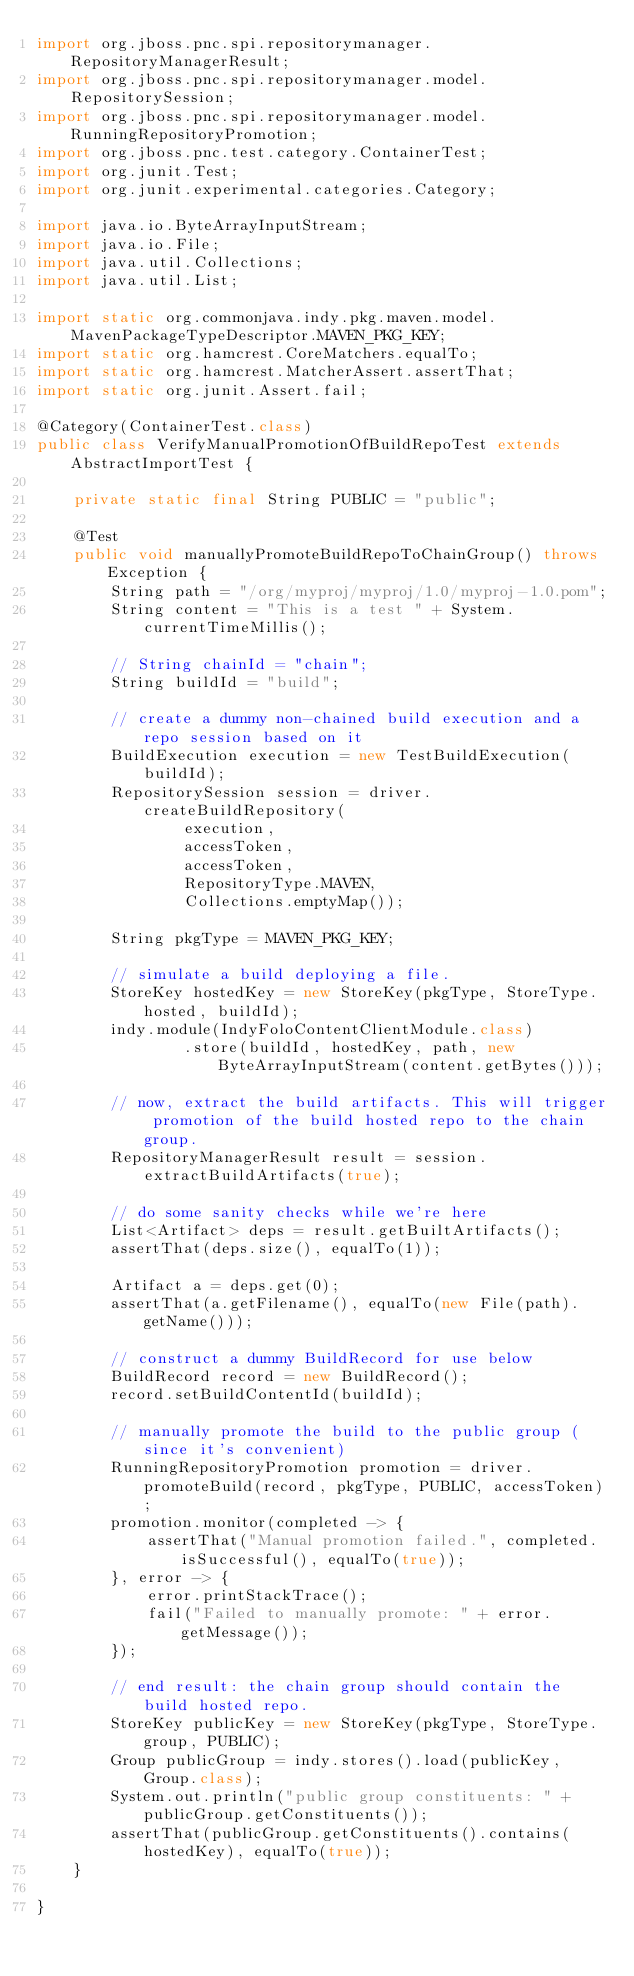<code> <loc_0><loc_0><loc_500><loc_500><_Java_>import org.jboss.pnc.spi.repositorymanager.RepositoryManagerResult;
import org.jboss.pnc.spi.repositorymanager.model.RepositorySession;
import org.jboss.pnc.spi.repositorymanager.model.RunningRepositoryPromotion;
import org.jboss.pnc.test.category.ContainerTest;
import org.junit.Test;
import org.junit.experimental.categories.Category;

import java.io.ByteArrayInputStream;
import java.io.File;
import java.util.Collections;
import java.util.List;

import static org.commonjava.indy.pkg.maven.model.MavenPackageTypeDescriptor.MAVEN_PKG_KEY;
import static org.hamcrest.CoreMatchers.equalTo;
import static org.hamcrest.MatcherAssert.assertThat;
import static org.junit.Assert.fail;

@Category(ContainerTest.class)
public class VerifyManualPromotionOfBuildRepoTest extends AbstractImportTest {

    private static final String PUBLIC = "public";

    @Test
    public void manuallyPromoteBuildRepoToChainGroup() throws Exception {
        String path = "/org/myproj/myproj/1.0/myproj-1.0.pom";
        String content = "This is a test " + System.currentTimeMillis();

        // String chainId = "chain";
        String buildId = "build";

        // create a dummy non-chained build execution and a repo session based on it
        BuildExecution execution = new TestBuildExecution(buildId);
        RepositorySession session = driver.createBuildRepository(
                execution,
                accessToken,
                accessToken,
                RepositoryType.MAVEN,
                Collections.emptyMap());

        String pkgType = MAVEN_PKG_KEY;

        // simulate a build deploying a file.
        StoreKey hostedKey = new StoreKey(pkgType, StoreType.hosted, buildId);
        indy.module(IndyFoloContentClientModule.class)
                .store(buildId, hostedKey, path, new ByteArrayInputStream(content.getBytes()));

        // now, extract the build artifacts. This will trigger promotion of the build hosted repo to the chain group.
        RepositoryManagerResult result = session.extractBuildArtifacts(true);

        // do some sanity checks while we're here
        List<Artifact> deps = result.getBuiltArtifacts();
        assertThat(deps.size(), equalTo(1));

        Artifact a = deps.get(0);
        assertThat(a.getFilename(), equalTo(new File(path).getName()));

        // construct a dummy BuildRecord for use below
        BuildRecord record = new BuildRecord();
        record.setBuildContentId(buildId);

        // manually promote the build to the public group (since it's convenient)
        RunningRepositoryPromotion promotion = driver.promoteBuild(record, pkgType, PUBLIC, accessToken);
        promotion.monitor(completed -> {
            assertThat("Manual promotion failed.", completed.isSuccessful(), equalTo(true));
        }, error -> {
            error.printStackTrace();
            fail("Failed to manually promote: " + error.getMessage());
        });

        // end result: the chain group should contain the build hosted repo.
        StoreKey publicKey = new StoreKey(pkgType, StoreType.group, PUBLIC);
        Group publicGroup = indy.stores().load(publicKey, Group.class);
        System.out.println("public group constituents: " + publicGroup.getConstituents());
        assertThat(publicGroup.getConstituents().contains(hostedKey), equalTo(true));
    }

}
</code> 